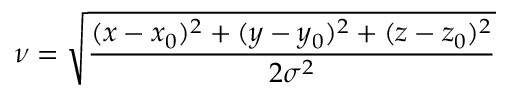Convert formula to latex. <formula><loc_0><loc_0><loc_500><loc_500>\nu = \sqrt { \frac { ( x - x _ { 0 } ) ^ { 2 } + ( y - y _ { 0 } ) ^ { 2 } + ( z - z _ { 0 } ) ^ { 2 } } { 2 \sigma ^ { 2 } } }</formula> 